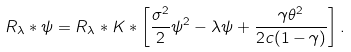Convert formula to latex. <formula><loc_0><loc_0><loc_500><loc_500>R _ { \lambda } * \psi = R _ { \lambda } * K * \left [ \frac { \sigma ^ { 2 } } { 2 } \psi ^ { 2 } - \lambda \psi + \frac { \gamma \theta ^ { 2 } } { 2 c ( 1 - \gamma ) } \right ] .</formula> 